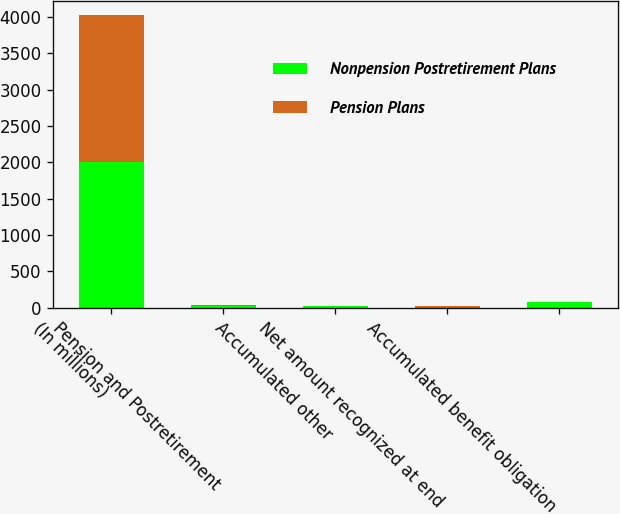Convert chart to OTSL. <chart><loc_0><loc_0><loc_500><loc_500><stacked_bar_chart><ecel><fcel>(In millions)<fcel>Pension and Postretirement<fcel>Accumulated other<fcel>Net amount recognized at end<fcel>Accumulated benefit obligation<nl><fcel>Nonpension Postretirement Plans<fcel>2011<fcel>17.6<fcel>17.7<fcel>0.1<fcel>85.4<nl><fcel>Pension Plans<fcel>2011<fcel>27.2<fcel>3.2<fcel>24<fcel>0<nl></chart> 